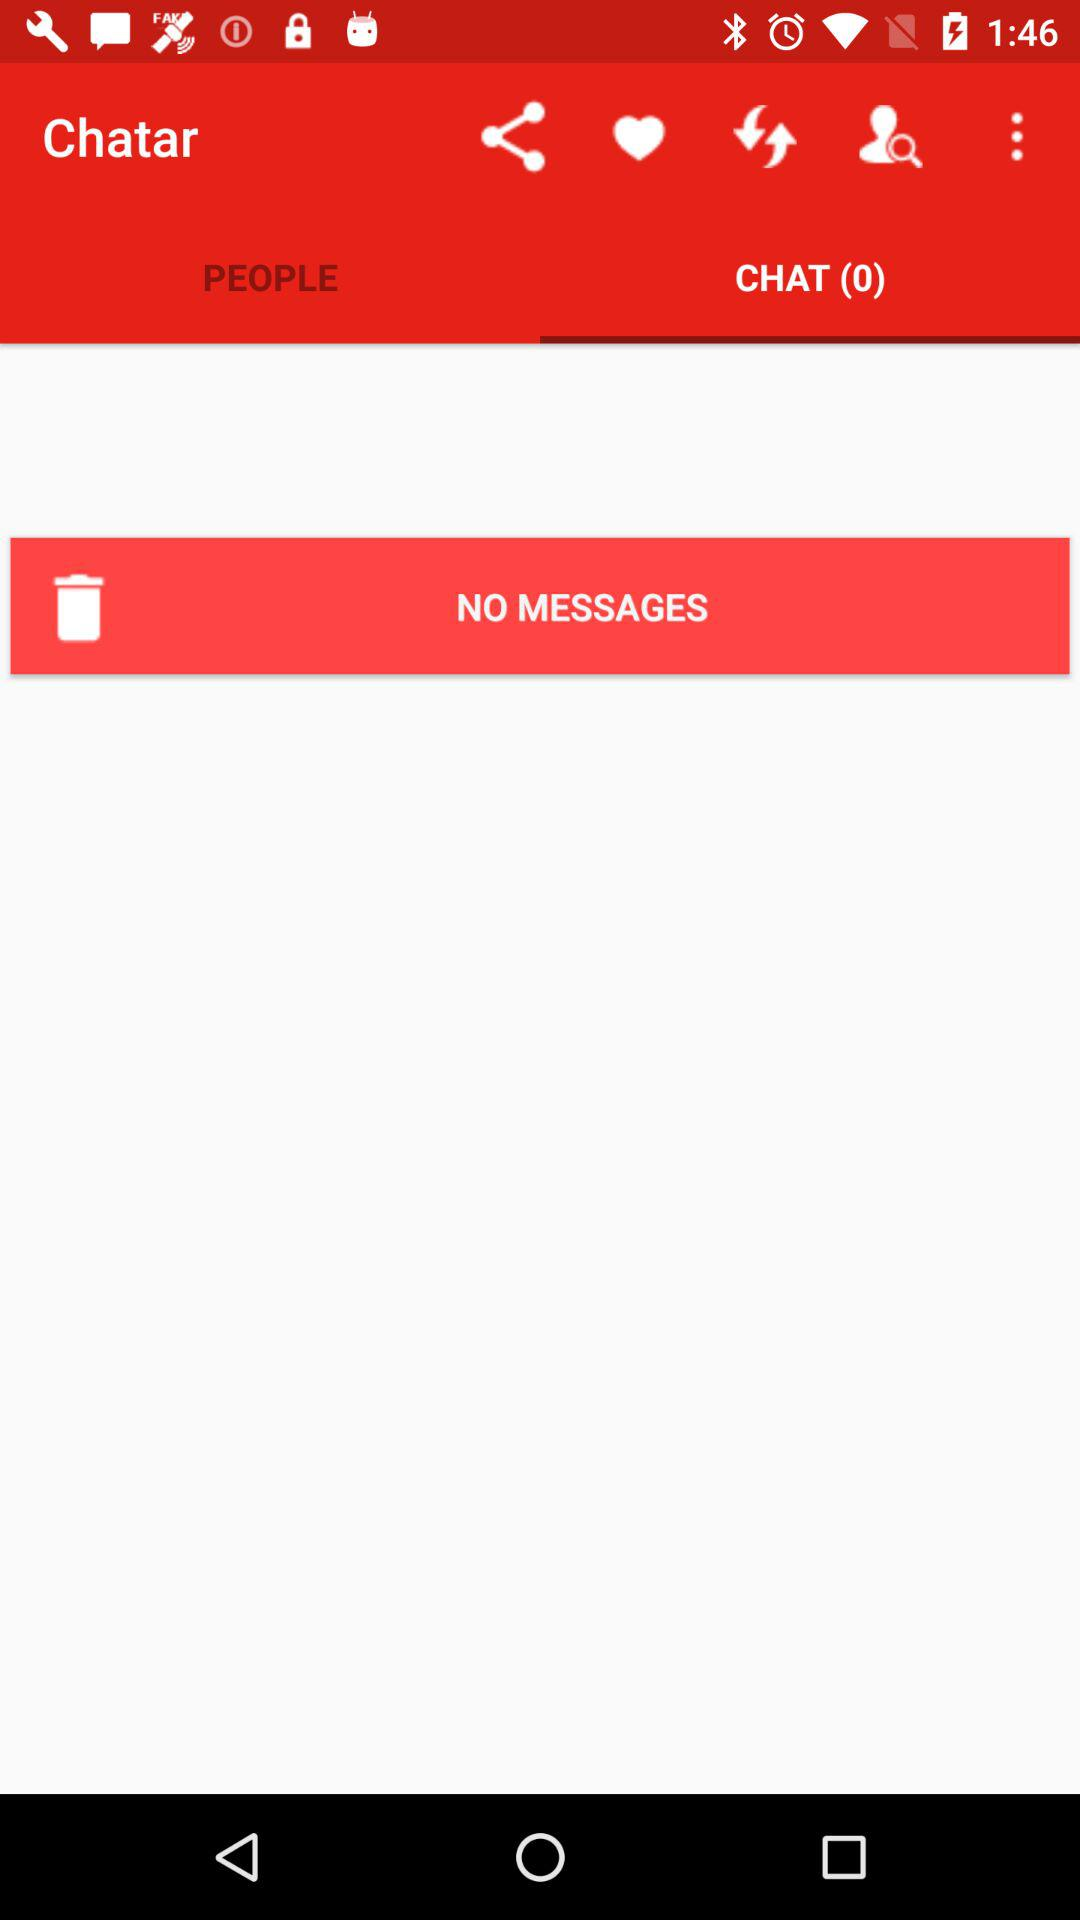Which option is selected in "Chatar"? The selected option in "Chatar" is "CHAT (0)". 